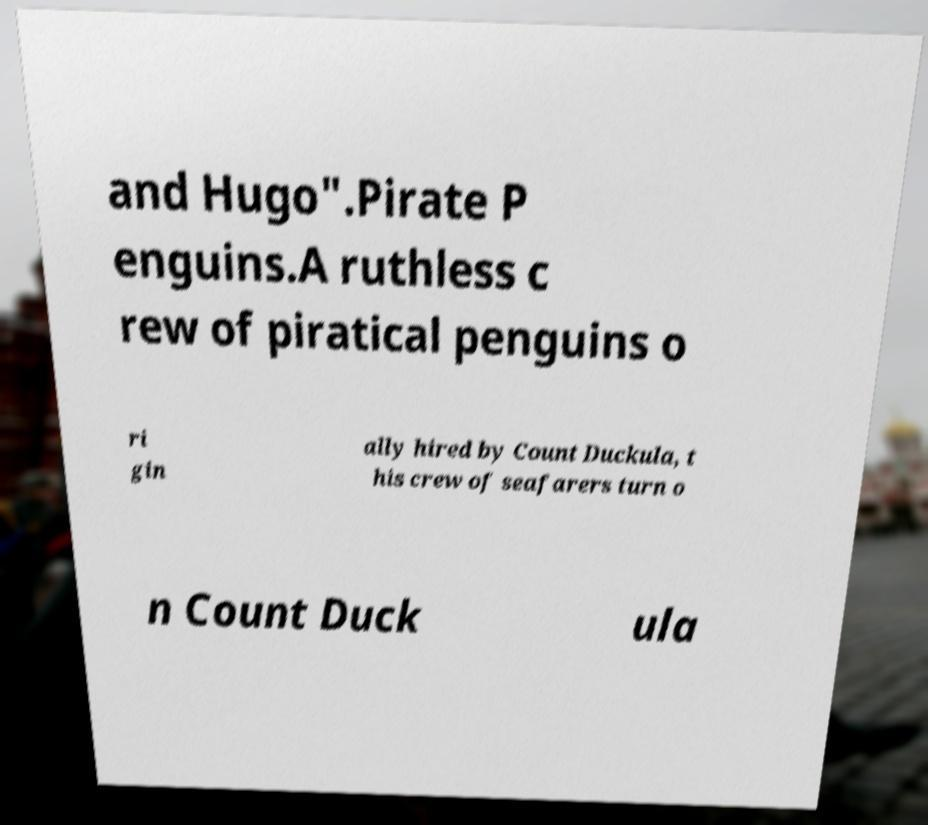Please identify and transcribe the text found in this image. and Hugo".Pirate P enguins.A ruthless c rew of piratical penguins o ri gin ally hired by Count Duckula, t his crew of seafarers turn o n Count Duck ula 